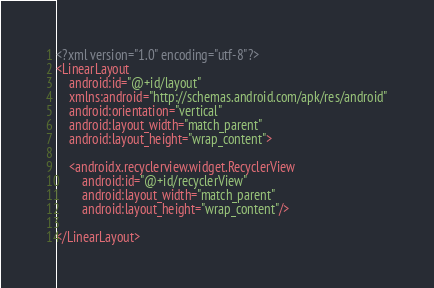<code> <loc_0><loc_0><loc_500><loc_500><_XML_><?xml version="1.0" encoding="utf-8"?>
<LinearLayout
    android:id="@+id/layout"
    xmlns:android="http://schemas.android.com/apk/res/android"
    android:orientation="vertical"
    android:layout_width="match_parent"
    android:layout_height="wrap_content">

    <androidx.recyclerview.widget.RecyclerView
        android:id="@+id/recyclerView"
        android:layout_width="match_parent"
        android:layout_height="wrap_content"/>

</LinearLayout></code> 